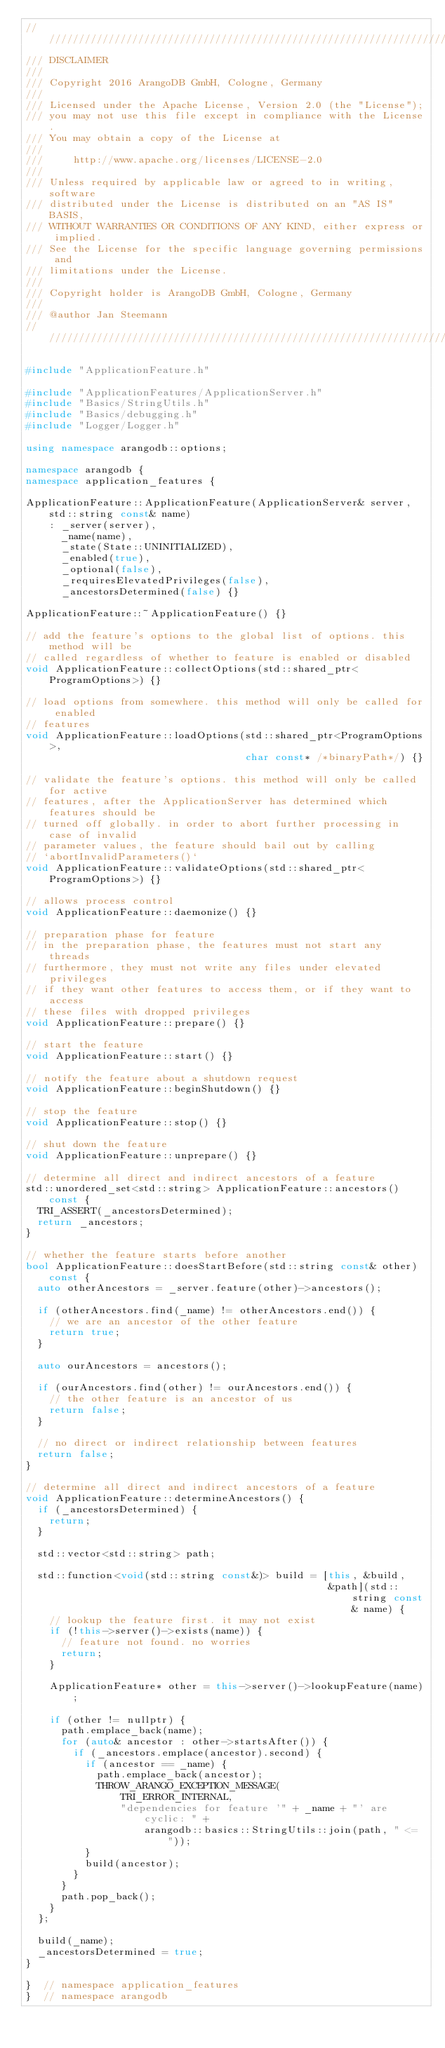<code> <loc_0><loc_0><loc_500><loc_500><_C++_>////////////////////////////////////////////////////////////////////////////////
/// DISCLAIMER
///
/// Copyright 2016 ArangoDB GmbH, Cologne, Germany
///
/// Licensed under the Apache License, Version 2.0 (the "License");
/// you may not use this file except in compliance with the License.
/// You may obtain a copy of the License at
///
///     http://www.apache.org/licenses/LICENSE-2.0
///
/// Unless required by applicable law or agreed to in writing, software
/// distributed under the License is distributed on an "AS IS" BASIS,
/// WITHOUT WARRANTIES OR CONDITIONS OF ANY KIND, either express or implied.
/// See the License for the specific language governing permissions and
/// limitations under the License.
///
/// Copyright holder is ArangoDB GmbH, Cologne, Germany
///
/// @author Jan Steemann
////////////////////////////////////////////////////////////////////////////////

#include "ApplicationFeature.h"

#include "ApplicationFeatures/ApplicationServer.h"
#include "Basics/StringUtils.h"
#include "Basics/debugging.h"
#include "Logger/Logger.h"

using namespace arangodb::options;

namespace arangodb {
namespace application_features {

ApplicationFeature::ApplicationFeature(ApplicationServer& server, std::string const& name)
    : _server(server),
      _name(name),
      _state(State::UNINITIALIZED),
      _enabled(true),
      _optional(false),
      _requiresElevatedPrivileges(false),
      _ancestorsDetermined(false) {}

ApplicationFeature::~ApplicationFeature() {}

// add the feature's options to the global list of options. this method will be
// called regardless of whether to feature is enabled or disabled
void ApplicationFeature::collectOptions(std::shared_ptr<ProgramOptions>) {}

// load options from somewhere. this method will only be called for enabled
// features
void ApplicationFeature::loadOptions(std::shared_ptr<ProgramOptions>,
                                     char const* /*binaryPath*/) {}

// validate the feature's options. this method will only be called for active
// features, after the ApplicationServer has determined which features should be
// turned off globally. in order to abort further processing in case of invalid
// parameter values, the feature should bail out by calling
// `abortInvalidParameters()`
void ApplicationFeature::validateOptions(std::shared_ptr<ProgramOptions>) {}

// allows process control
void ApplicationFeature::daemonize() {}

// preparation phase for feature
// in the preparation phase, the features must not start any threads
// furthermore, they must not write any files under elevated privileges
// if they want other features to access them, or if they want to access
// these files with dropped privileges
void ApplicationFeature::prepare() {}

// start the feature
void ApplicationFeature::start() {}

// notify the feature about a shutdown request
void ApplicationFeature::beginShutdown() {}

// stop the feature
void ApplicationFeature::stop() {}

// shut down the feature
void ApplicationFeature::unprepare() {}

// determine all direct and indirect ancestors of a feature
std::unordered_set<std::string> ApplicationFeature::ancestors() const {
  TRI_ASSERT(_ancestorsDetermined);
  return _ancestors;
}

// whether the feature starts before another
bool ApplicationFeature::doesStartBefore(std::string const& other) const {
  auto otherAncestors = _server.feature(other)->ancestors();

  if (otherAncestors.find(_name) != otherAncestors.end()) {
    // we are an ancestor of the other feature
    return true;
  }

  auto ourAncestors = ancestors();

  if (ourAncestors.find(other) != ourAncestors.end()) {
    // the other feature is an ancestor of us
    return false;
  }

  // no direct or indirect relationship between features
  return false;
}

// determine all direct and indirect ancestors of a feature
void ApplicationFeature::determineAncestors() {
  if (_ancestorsDetermined) {
    return;
  }

  std::vector<std::string> path;

  std::function<void(std::string const&)> build = [this, &build,
                                                   &path](std::string const& name) {
    // lookup the feature first. it may not exist
    if (!this->server()->exists(name)) {
      // feature not found. no worries
      return;
    }

    ApplicationFeature* other = this->server()->lookupFeature(name);

    if (other != nullptr) {
      path.emplace_back(name);
      for (auto& ancestor : other->startsAfter()) {
        if (_ancestors.emplace(ancestor).second) {
          if (ancestor == _name) {
            path.emplace_back(ancestor);
            THROW_ARANGO_EXCEPTION_MESSAGE(
                TRI_ERROR_INTERNAL,
                "dependencies for feature '" + _name + "' are cyclic: " +
                    arangodb::basics::StringUtils::join(path, " <= "));
          }
          build(ancestor);
        }
      }
      path.pop_back();
    }
  };

  build(_name);
  _ancestorsDetermined = true;
}

}  // namespace application_features
}  // namespace arangodb
</code> 